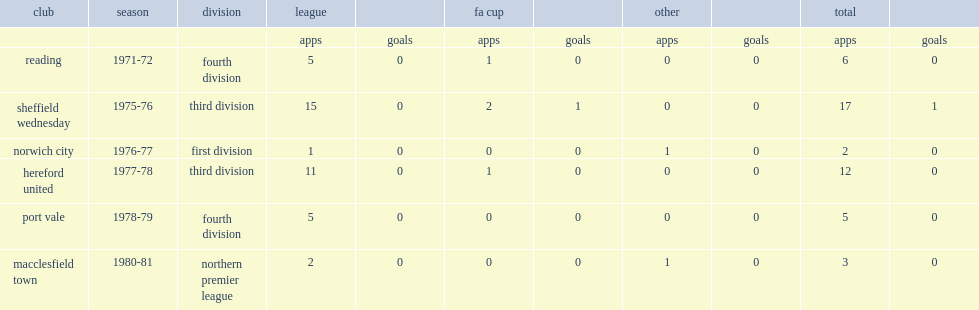What was the number of appearances made by proudlove for reading in the 1971-72 season? 5.0. 